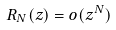Convert formula to latex. <formula><loc_0><loc_0><loc_500><loc_500>R _ { N } ( z ) = o ( z ^ { N } )</formula> 